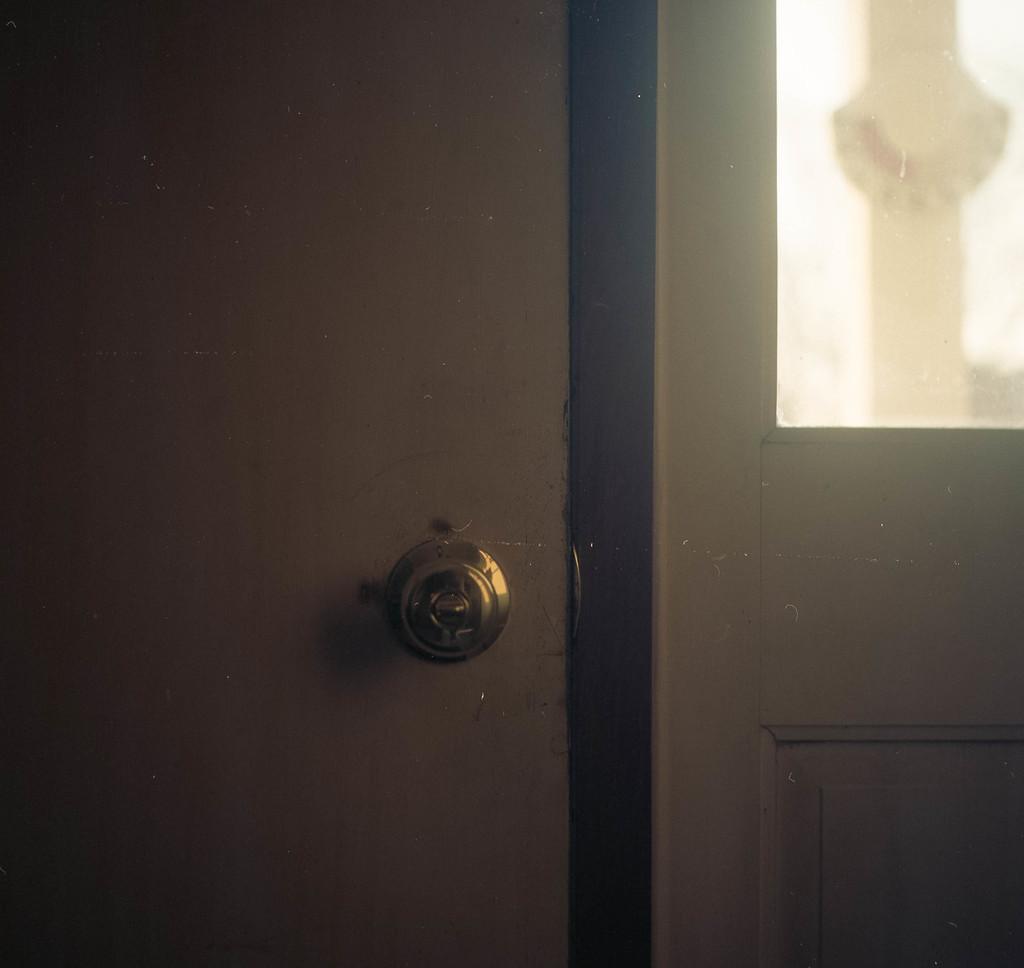Could you give a brief overview of what you see in this image? In this picture we can see a door. 